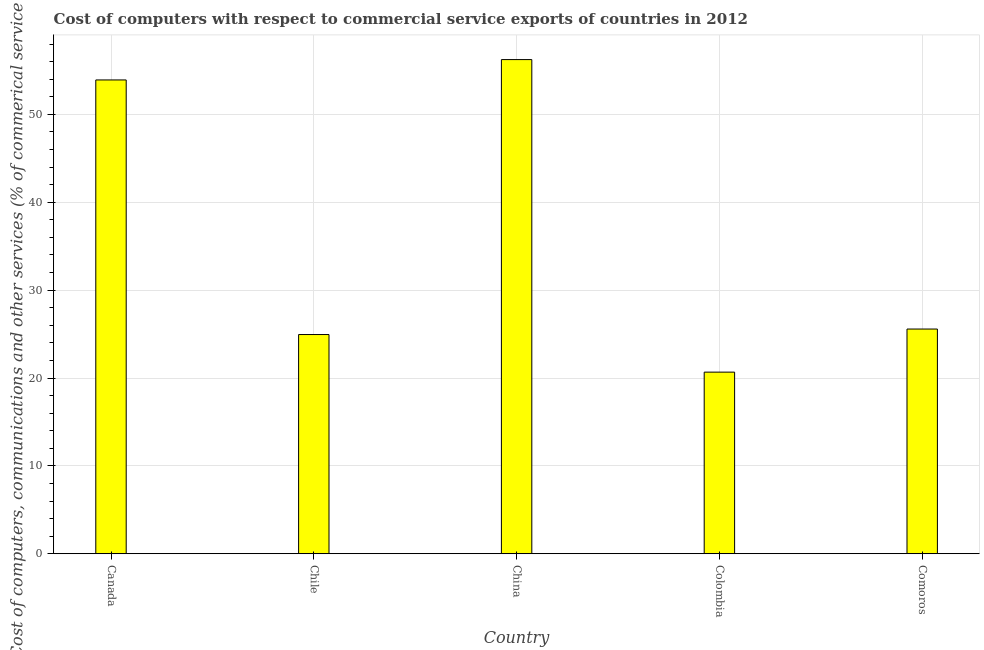What is the title of the graph?
Provide a succinct answer. Cost of computers with respect to commercial service exports of countries in 2012. What is the label or title of the Y-axis?
Make the answer very short. Cost of computers, communications and other services (% of commerical service exports). What is the  computer and other services in Canada?
Provide a short and direct response. 53.92. Across all countries, what is the maximum cost of communications?
Your answer should be compact. 56.24. Across all countries, what is the minimum  computer and other services?
Make the answer very short. 20.67. In which country was the cost of communications maximum?
Ensure brevity in your answer.  China. What is the sum of the  computer and other services?
Your answer should be very brief. 181.35. What is the difference between the cost of communications in Chile and China?
Offer a terse response. -31.29. What is the average  computer and other services per country?
Make the answer very short. 36.27. What is the median cost of communications?
Give a very brief answer. 25.57. In how many countries, is the  computer and other services greater than 44 %?
Keep it short and to the point. 2. What is the ratio of the  computer and other services in China to that in Comoros?
Give a very brief answer. 2.2. Is the cost of communications in China less than that in Comoros?
Give a very brief answer. No. What is the difference between the highest and the second highest  computer and other services?
Provide a succinct answer. 2.32. Is the sum of the  computer and other services in Canada and Chile greater than the maximum  computer and other services across all countries?
Keep it short and to the point. Yes. What is the difference between the highest and the lowest  computer and other services?
Give a very brief answer. 35.57. How many bars are there?
Offer a terse response. 5. How many countries are there in the graph?
Offer a terse response. 5. What is the difference between two consecutive major ticks on the Y-axis?
Make the answer very short. 10. What is the Cost of computers, communications and other services (% of commerical service exports) in Canada?
Your answer should be compact. 53.92. What is the Cost of computers, communications and other services (% of commerical service exports) in Chile?
Ensure brevity in your answer.  24.95. What is the Cost of computers, communications and other services (% of commerical service exports) of China?
Keep it short and to the point. 56.24. What is the Cost of computers, communications and other services (% of commerical service exports) in Colombia?
Make the answer very short. 20.67. What is the Cost of computers, communications and other services (% of commerical service exports) of Comoros?
Your answer should be very brief. 25.57. What is the difference between the Cost of computers, communications and other services (% of commerical service exports) in Canada and Chile?
Offer a terse response. 28.98. What is the difference between the Cost of computers, communications and other services (% of commerical service exports) in Canada and China?
Ensure brevity in your answer.  -2.32. What is the difference between the Cost of computers, communications and other services (% of commerical service exports) in Canada and Colombia?
Ensure brevity in your answer.  33.25. What is the difference between the Cost of computers, communications and other services (% of commerical service exports) in Canada and Comoros?
Provide a short and direct response. 28.35. What is the difference between the Cost of computers, communications and other services (% of commerical service exports) in Chile and China?
Keep it short and to the point. -31.29. What is the difference between the Cost of computers, communications and other services (% of commerical service exports) in Chile and Colombia?
Your response must be concise. 4.28. What is the difference between the Cost of computers, communications and other services (% of commerical service exports) in Chile and Comoros?
Your answer should be very brief. -0.63. What is the difference between the Cost of computers, communications and other services (% of commerical service exports) in China and Colombia?
Offer a terse response. 35.57. What is the difference between the Cost of computers, communications and other services (% of commerical service exports) in China and Comoros?
Provide a short and direct response. 30.67. What is the difference between the Cost of computers, communications and other services (% of commerical service exports) in Colombia and Comoros?
Ensure brevity in your answer.  -4.91. What is the ratio of the Cost of computers, communications and other services (% of commerical service exports) in Canada to that in Chile?
Offer a very short reply. 2.16. What is the ratio of the Cost of computers, communications and other services (% of commerical service exports) in Canada to that in China?
Offer a very short reply. 0.96. What is the ratio of the Cost of computers, communications and other services (% of commerical service exports) in Canada to that in Colombia?
Your response must be concise. 2.61. What is the ratio of the Cost of computers, communications and other services (% of commerical service exports) in Canada to that in Comoros?
Offer a terse response. 2.11. What is the ratio of the Cost of computers, communications and other services (% of commerical service exports) in Chile to that in China?
Provide a succinct answer. 0.44. What is the ratio of the Cost of computers, communications and other services (% of commerical service exports) in Chile to that in Colombia?
Provide a succinct answer. 1.21. What is the ratio of the Cost of computers, communications and other services (% of commerical service exports) in Chile to that in Comoros?
Your answer should be compact. 0.97. What is the ratio of the Cost of computers, communications and other services (% of commerical service exports) in China to that in Colombia?
Make the answer very short. 2.72. What is the ratio of the Cost of computers, communications and other services (% of commerical service exports) in China to that in Comoros?
Your answer should be compact. 2.2. What is the ratio of the Cost of computers, communications and other services (% of commerical service exports) in Colombia to that in Comoros?
Keep it short and to the point. 0.81. 